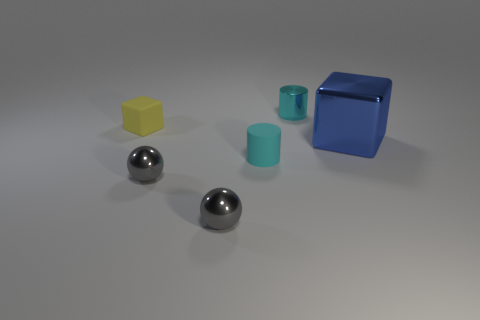Add 2 large metallic things. How many objects exist? 8 Subtract all blocks. How many objects are left? 4 Add 5 small shiny objects. How many small shiny objects exist? 8 Subtract 0 yellow balls. How many objects are left? 6 Subtract all big red matte balls. Subtract all cyan cylinders. How many objects are left? 4 Add 1 rubber cylinders. How many rubber cylinders are left? 2 